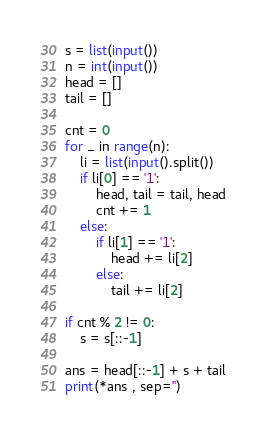<code> <loc_0><loc_0><loc_500><loc_500><_Python_>s = list(input())
n = int(input())
head = []
tail = []

cnt = 0
for _ in range(n):
    li = list(input().split())
    if li[0] == '1':
        head, tail = tail, head
        cnt += 1
    else:
        if li[1] == '1':
            head += li[2]
        else:
            tail += li[2]

if cnt % 2 != 0:
    s = s[::-1]

ans = head[::-1] + s + tail
print(*ans , sep='')</code> 